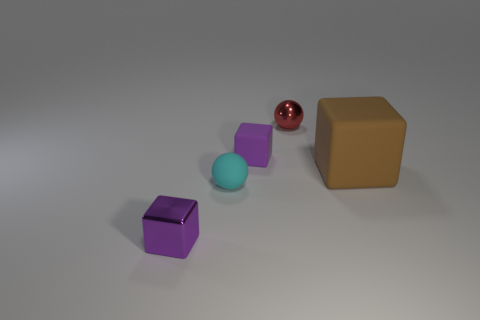Add 4 small cyan balls. How many objects exist? 9 Subtract all balls. How many objects are left? 3 Subtract all small red metal cylinders. Subtract all big brown things. How many objects are left? 4 Add 5 small red metallic things. How many small red metallic things are left? 6 Add 4 purple objects. How many purple objects exist? 6 Subtract 1 brown cubes. How many objects are left? 4 